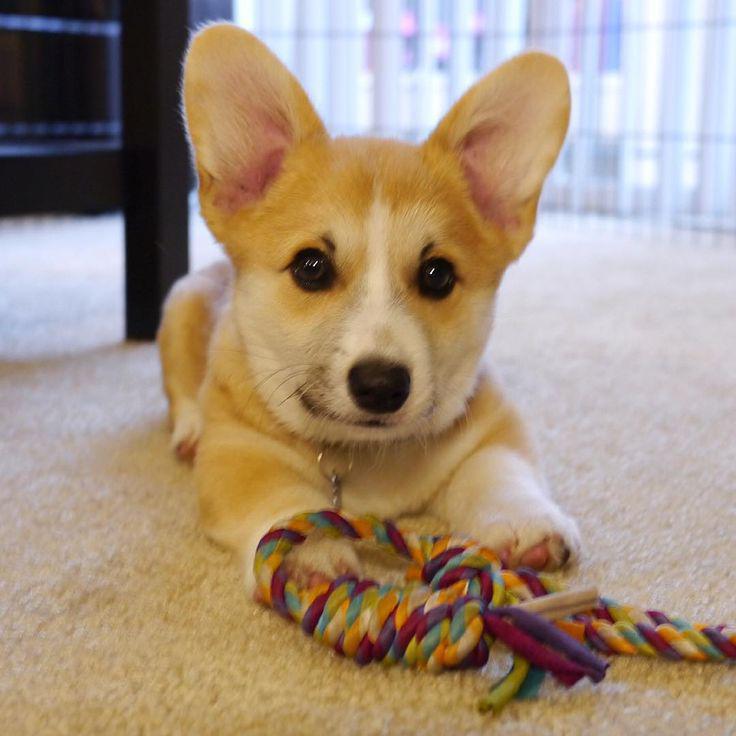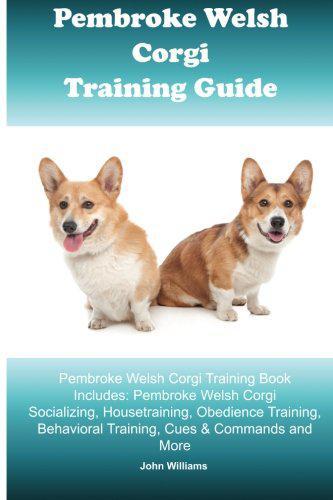The first image is the image on the left, the second image is the image on the right. Evaluate the accuracy of this statement regarding the images: "The dog in the image on the right is near a body of water.". Is it true? Answer yes or no. No. The first image is the image on the left, the second image is the image on the right. Given the left and right images, does the statement "An image shows one orange-and-white corgi dog posed on the shore in front of water and looking at the camera." hold true? Answer yes or no. No. 